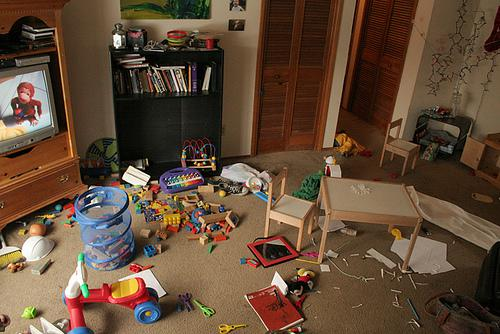Question: what is the state of the room?
Choices:
A. Clean.
B. Messy.
C. Freshly painted.
D. Burned.
Answer with the letter. Answer: B Question: where are the toys?
Choices:
A. Everywhere.
B. In the boxes.
C. On the shelf.
D. In the closet.
Answer with the letter. Answer: A 